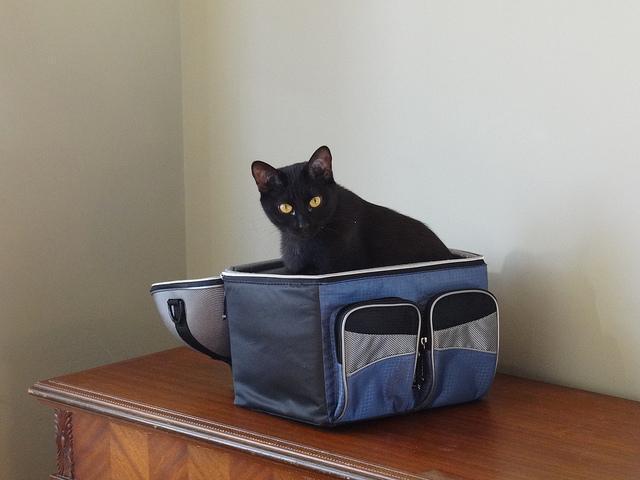How many airplanes are in front of the control towers?
Give a very brief answer. 0. 